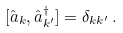<formula> <loc_0><loc_0><loc_500><loc_500>[ \hat { a } _ { k } , \hat { a } ^ { \dagger } _ { k ^ { \prime } } ] = \delta _ { k k ^ { \prime } } \, .</formula> 